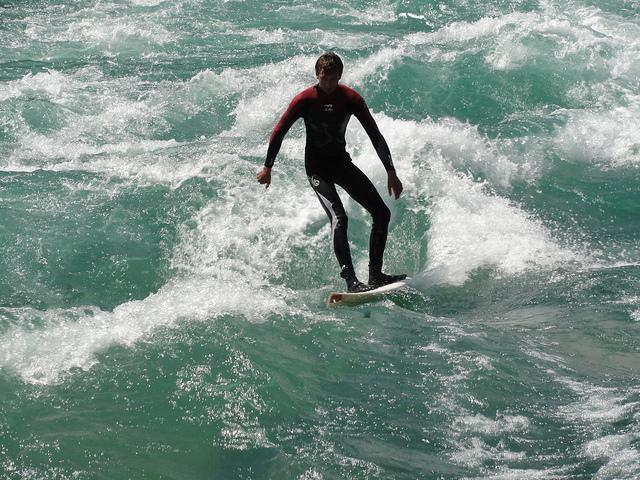How many black umbrellas are there?
Give a very brief answer. 0. 